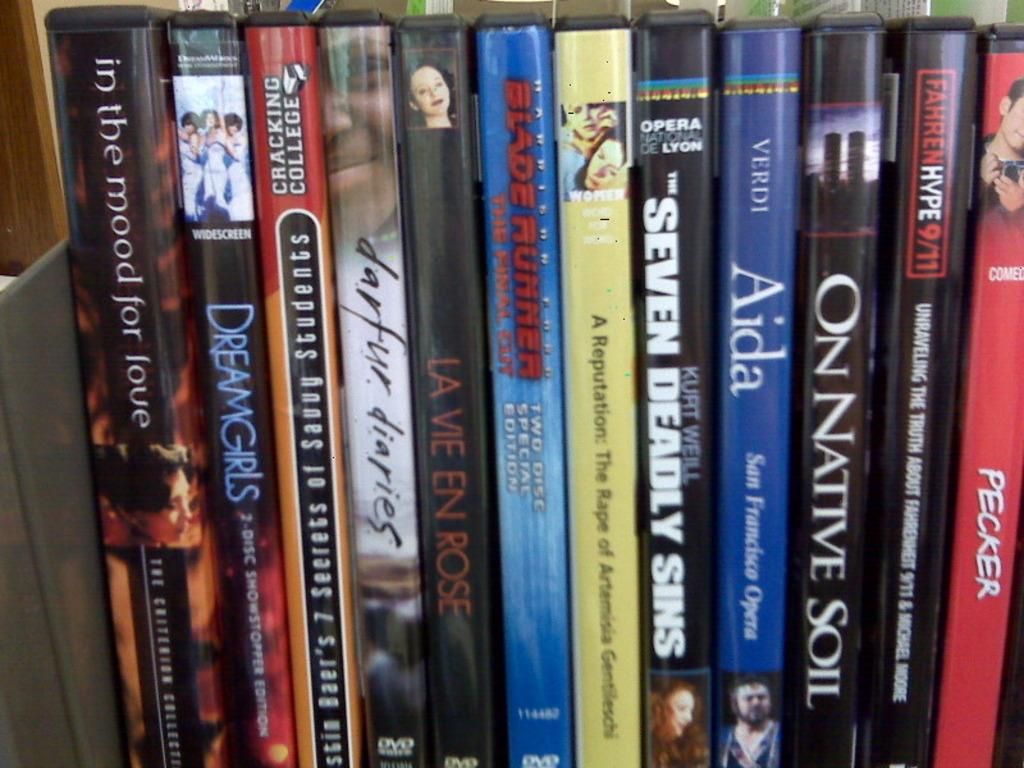What is the title of the book to the far left?
Offer a very short reply. In the mood for love. What movie is on the far right?
Give a very brief answer. Pecker. 